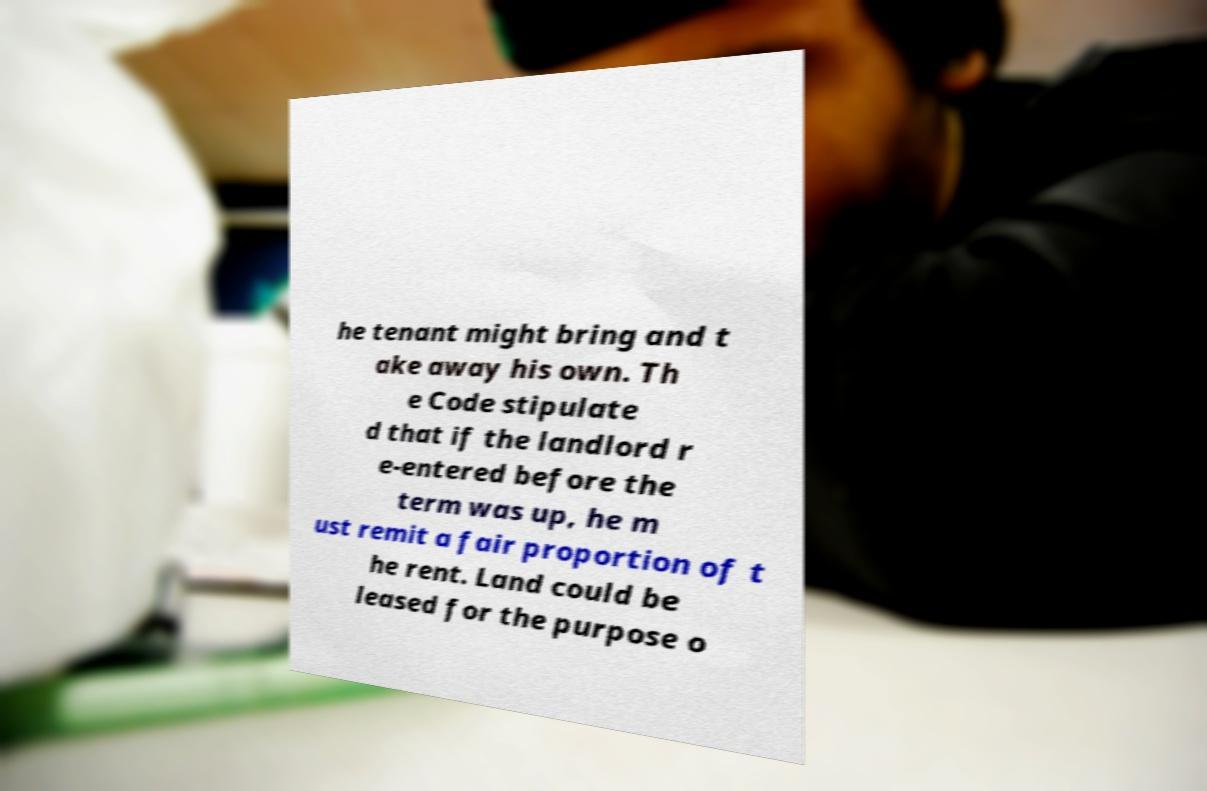Please identify and transcribe the text found in this image. he tenant might bring and t ake away his own. Th e Code stipulate d that if the landlord r e-entered before the term was up, he m ust remit a fair proportion of t he rent. Land could be leased for the purpose o 